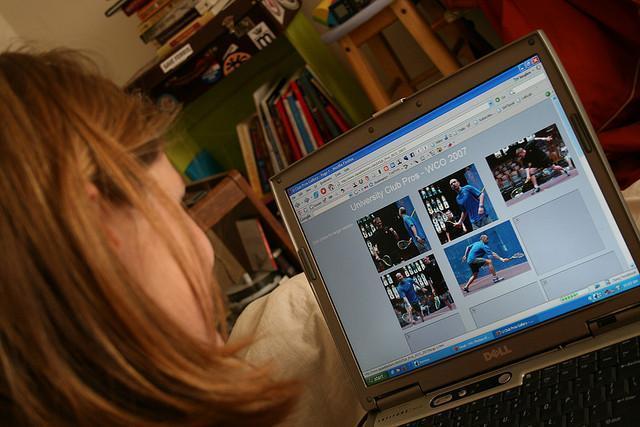How many comps are there?
Give a very brief answer. 1. How many of the train carts have red around the windows?
Give a very brief answer. 0. 